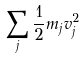<formula> <loc_0><loc_0><loc_500><loc_500>\sum _ { j } \frac { 1 } { 2 } m _ { j } v _ { j } ^ { 2 }</formula> 